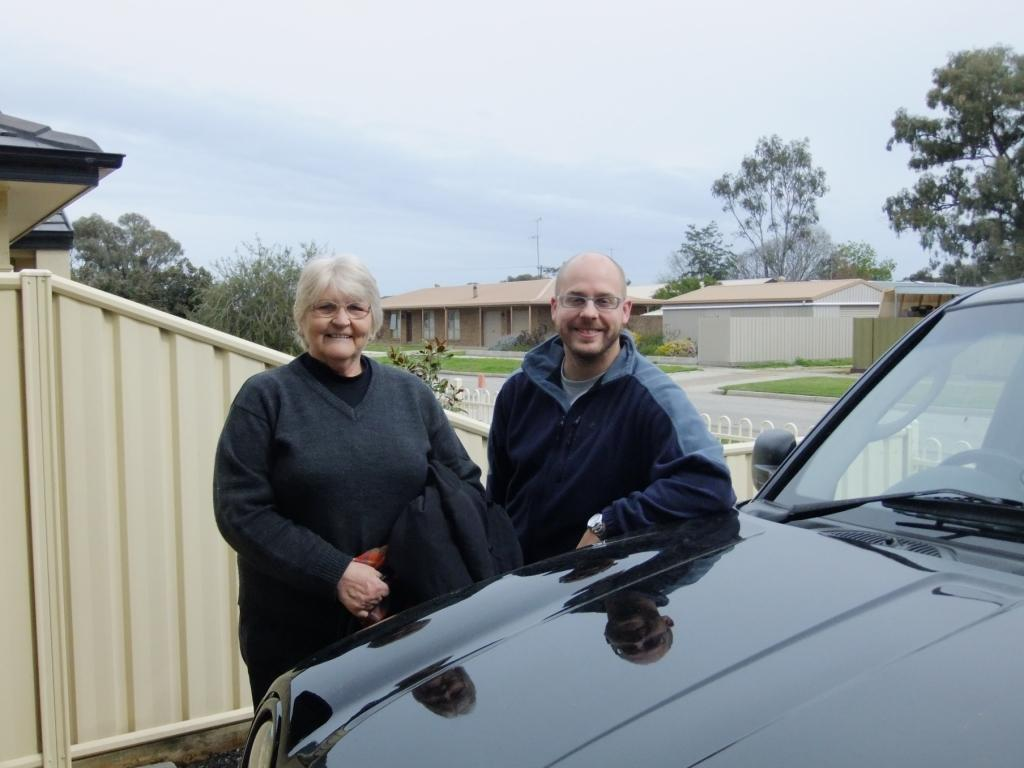How many people are present in the image? There are two people, a woman and a man, present in the image. What expressions do the woman and the man have? Both the woman and the man are smiling in the image. What accessory do the woman and the man have in common? The woman and the man are both wearing spectacles. What vehicle can be seen in the image? There is a car in the image. What type of natural environment is visible in the image? Trees, grass, and plants are visible in the image. What is visible in the background of the image? The sky is visible in the background of the image. What condition is the cannon in, and where is it located in the image? There is no cannon present in the image. How many geese are visible in the image? There are no geese visible in the image. 